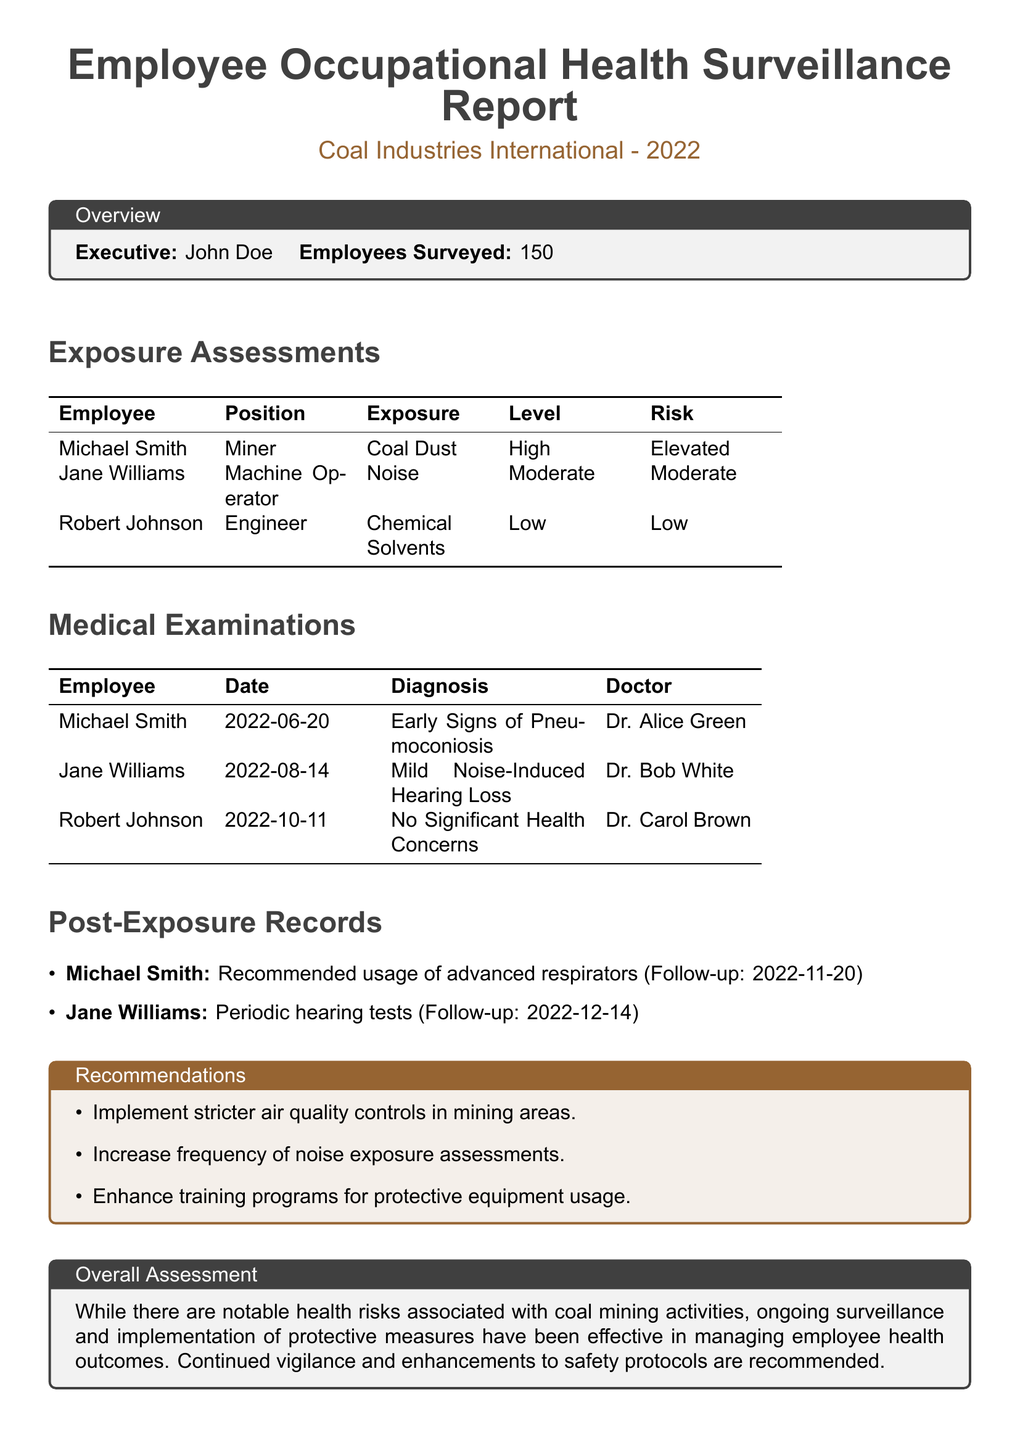What is the total number of employees surveyed? The document states that the total number of employees surveyed is 150.
Answer: 150 Who diagnosed Michael Smith's condition? Michael Smith's condition was diagnosed by Dr. Alice Green.
Answer: Dr. Alice Green What type of exposure did Jane Williams face? Jane Williams was exposed to noise.
Answer: Noise What is the recommended follow-up date for Michael Smith? The follow-up date recommended for Michael Smith is 2022-11-20.
Answer: 2022-11-20 What was Robert Johnson's diagnosis? Robert Johnson had no significant health concerns.
Answer: No Significant Health Concerns What health recommendation is made for enhancing safety? One recommendation is to implement stricter air quality controls in mining areas.
Answer: Stricter air quality controls Which employee has early signs of pneumoconiosis? The employee with early signs of pneumoconiosis is Michael Smith.
Answer: Michael Smith What was the risk level for coal dust exposure? The risk level for coal dust exposure is elevated.
Answer: Elevated What is the date of Jane Williams' medical examination? Jane Williams' medical examination took place on 2022-08-14.
Answer: 2022-08-14 